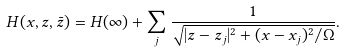<formula> <loc_0><loc_0><loc_500><loc_500>H ( x , z , \bar { z } ) = H ( \infty ) + \sum _ { j } \frac { 1 } { \sqrt { | z - z _ { j } | ^ { 2 } + ( x - x _ { j } ) ^ { 2 } / \Omega } } .</formula> 